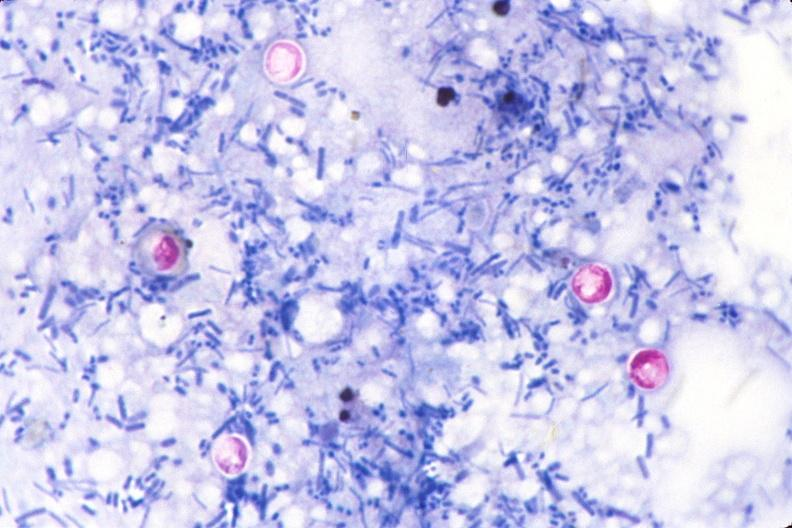what is present?
Answer the question using a single word or phrase. Gastrointestinal 